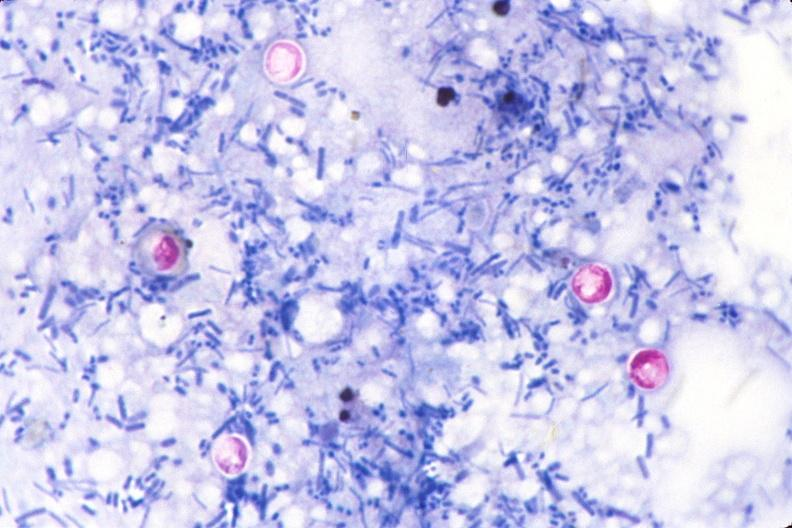what is present?
Answer the question using a single word or phrase. Gastrointestinal 